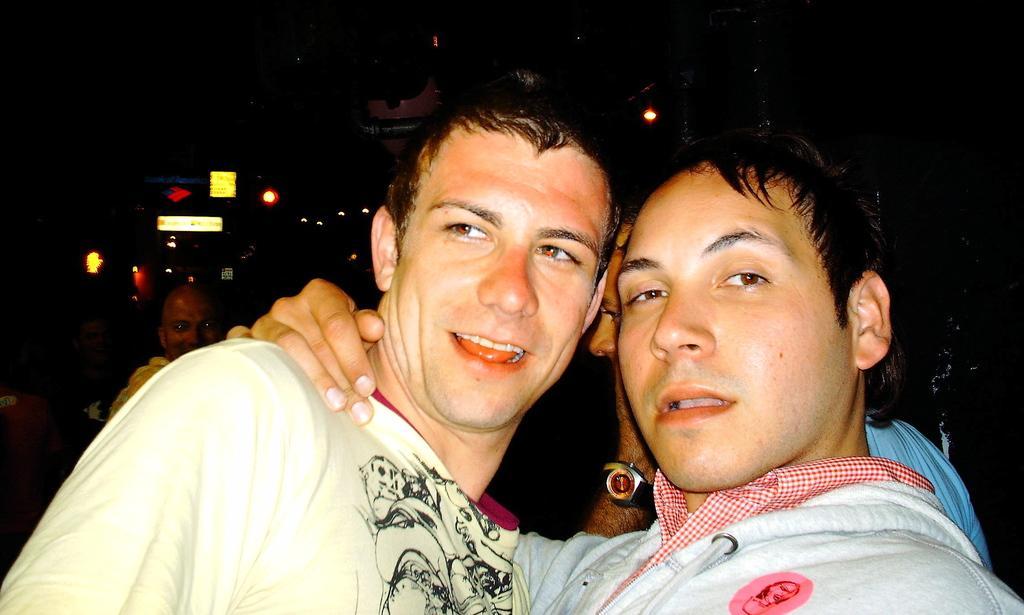Please provide a concise description of this image. In this picture we can see two men. There are a few people and some lights are visible in the background. We can see a dark background. 